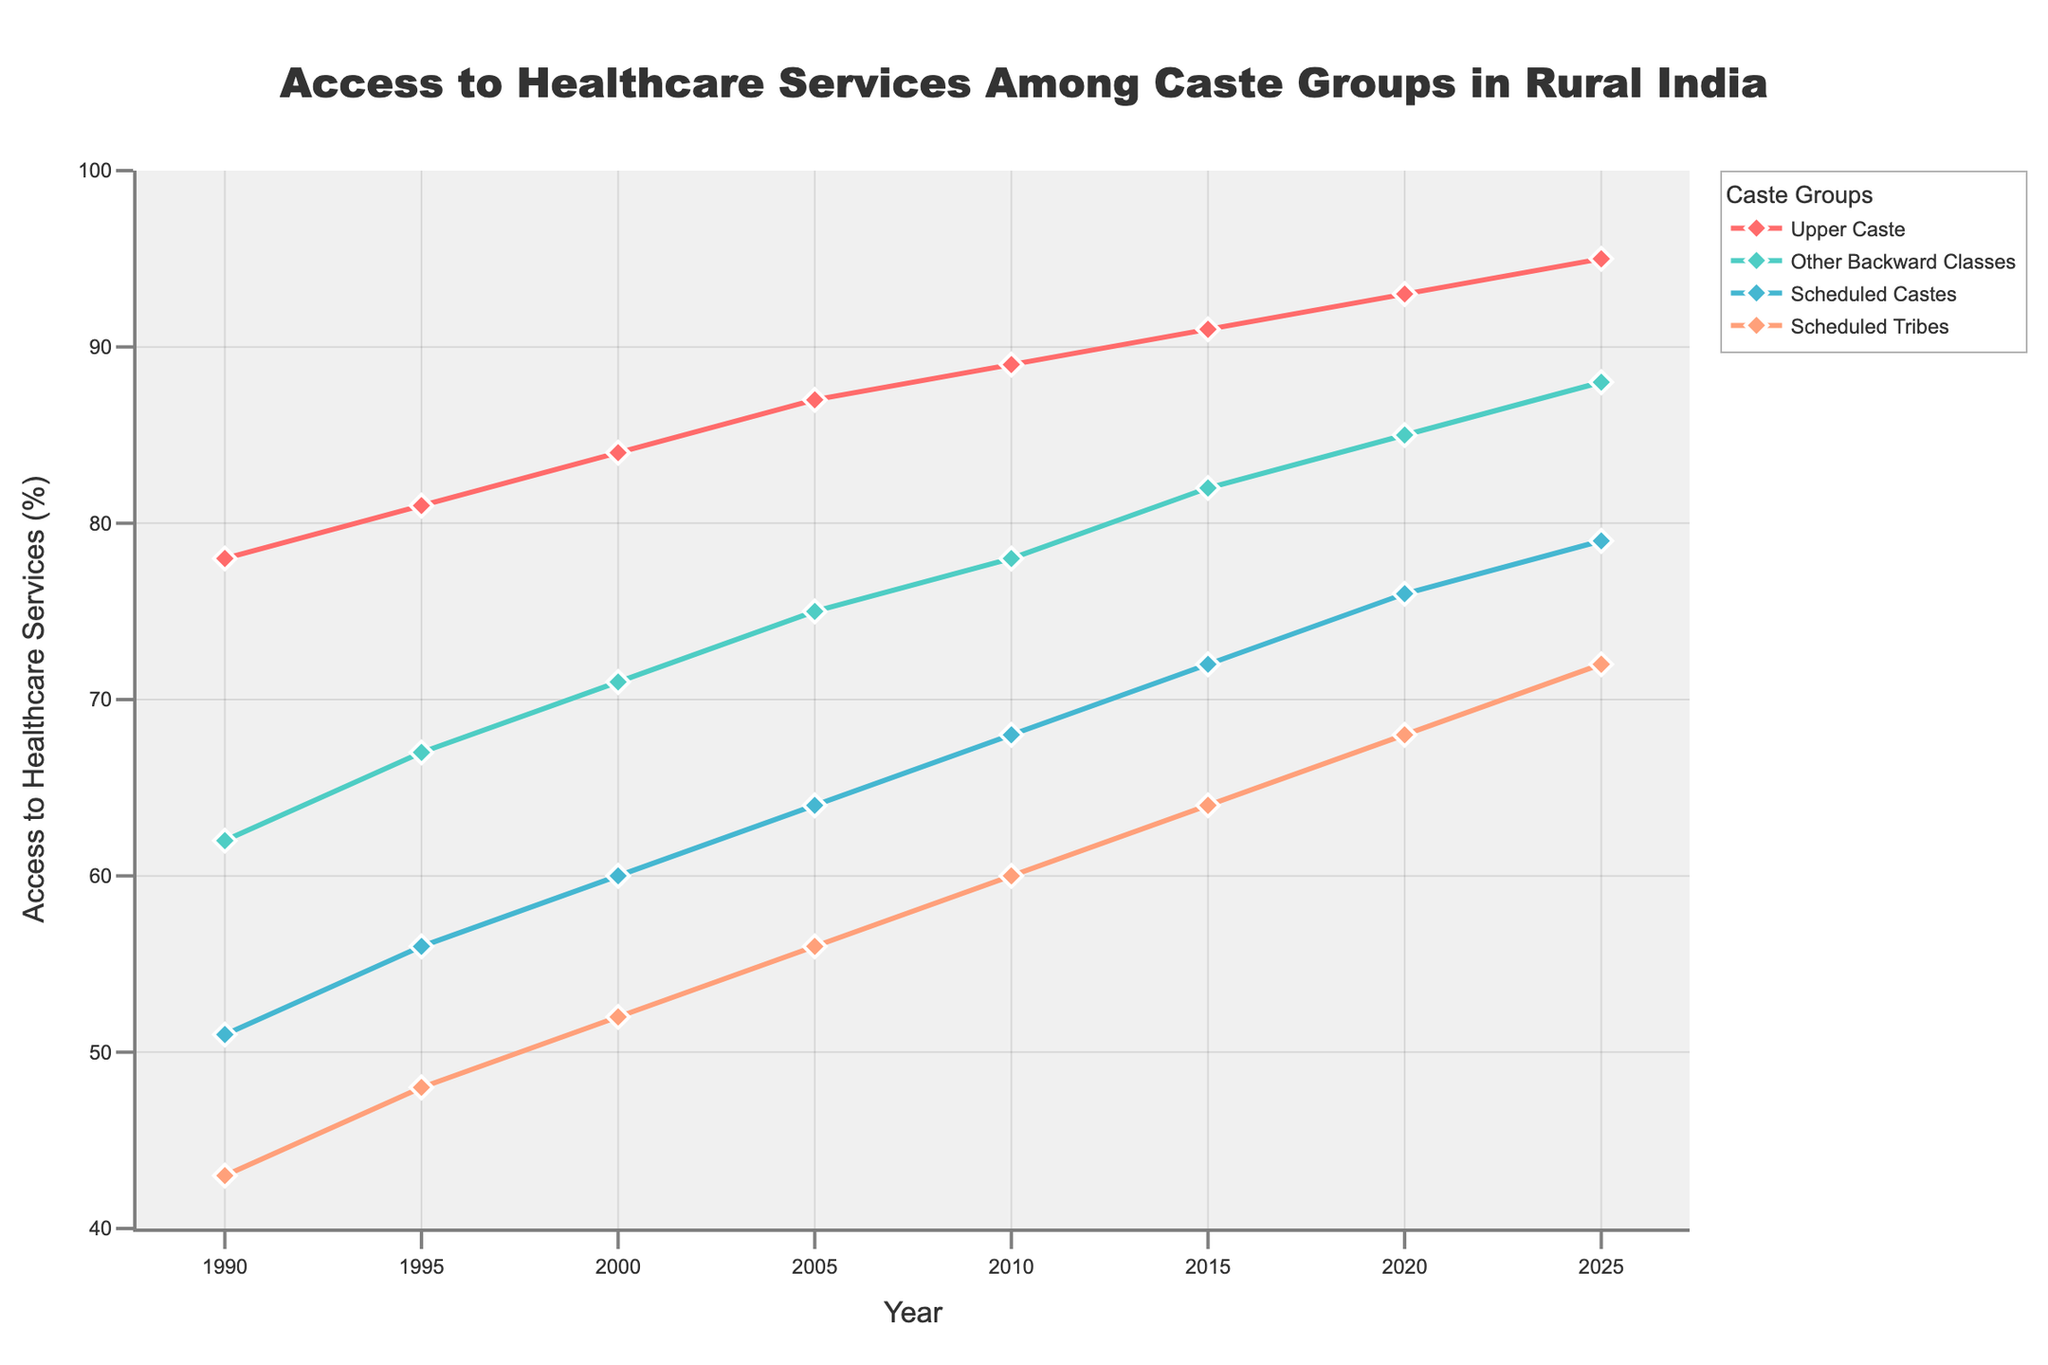What caste group experienced the highest increase in access to healthcare services from 1990 to 2025? The increase can be calculated by finding the difference between the values in 2025 and 1990 for each group. Upper Caste: 95-78=17, Other Backward Classes: 88-62=26, Scheduled Castes: 79-51=28, Scheduled Tribes: 72-43=29. The greatest increase is for Scheduled Tribes at 29.
Answer: Scheduled Tribes Which caste group consistently had the lowest access to healthcare services throughout the period? By visually tracing the lowest line across the time range, we can see that the line representing the Scheduled Tribes is consistently at the bottom.
Answer: Scheduled Tribes In which year did Upper Caste first achieve an access value greater than 80%? By observing the trend line for the Upper Caste, it crosses 80% between 1995 and 2000. Specifically, in 2000 the value is 84%.
Answer: 2000 How does the access to healthcare services in 2025 for Scheduled Castes compare to Upper Caste in 1990? In 2025, Scheduled Castes have a value of 79%. The value for Upper Caste in 1990 is 78%. Therefore, in 2025, Scheduled Castes have a higher access percentage than Upper Caste in 1990 by 1%.
Answer: Scheduled Castes in 2025 have higher access Considering all caste groups, what is the average access to healthcare services in the year 2000? Sum the access percentages for all caste groups in 2000 and divide by the number of groups: (84 + 71 + 60 + 52)/4 = 267/4 = 66.75
Answer: 66.75 What can be inferred about the trend in access to healthcare services for Other Backward Classes from 1990 to 2025? By observing the trend line for Other Backward Classes, it shows a consistent upward trend from 62% to 88%. This indicates a significant improvement over time.
Answer: Consistent improvement Which caste group had the smallest increase in access to healthcare services from 2015 to 2020? Calculate the difference between values for each group from 2015 to 2020. Upper Caste: 93-91=2, Other Backward Classes: 85-82=3, Scheduled Castes: 76-72=4, Scheduled Tribes: 68-64=4. The Upper Caste had the smallest increase of 2%.
Answer: Upper Caste What is the difference in healthcare access between Scheduled Castes and Scheduled Tribes in 1990 and 2025? Difference in 1990: 51 - 43 = 8. Difference in 2025: 79 - 72 = 7. Hence, the difference decreases from 8 in 1990 to 7 in 2025.
Answer: Decreases by 1 Which caste group had access to healthcare services greater than 65% by 2010? The values in 2010 are: Upper Caste: 89, Other Backward Classes: 78, Scheduled Castes: 68, Scheduled Tribes: 60. All groups except Scheduled Tribes had access greater than 65%.
Answer: Upper Caste, Other Backward Classes, Scheduled Castes What is the combined percentage increase for Scheduled Castes and Scheduled Tribes from 1990 to 2000? Calculate the individual increases: Scheduled Castes: 60-51=9, Scheduled Tribes: 52-43=9. Combined increase is 9+9=18.
Answer: 18 